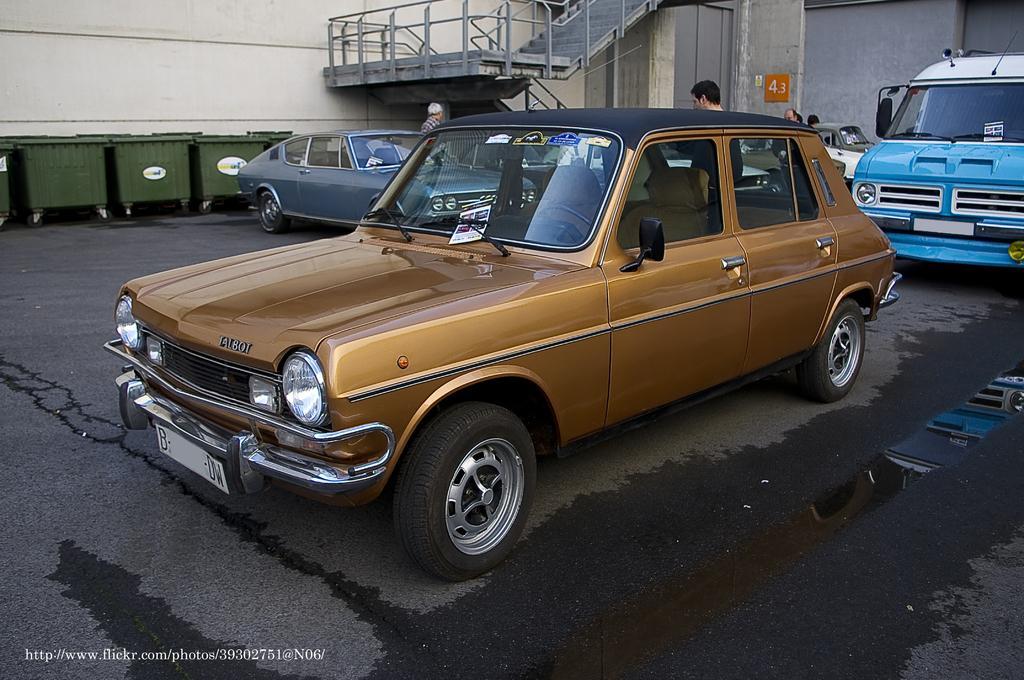Describe this image in one or two sentences. In this image there are few vehicles and people, there are stairs, trolleys and a poster on the wall of the building. 